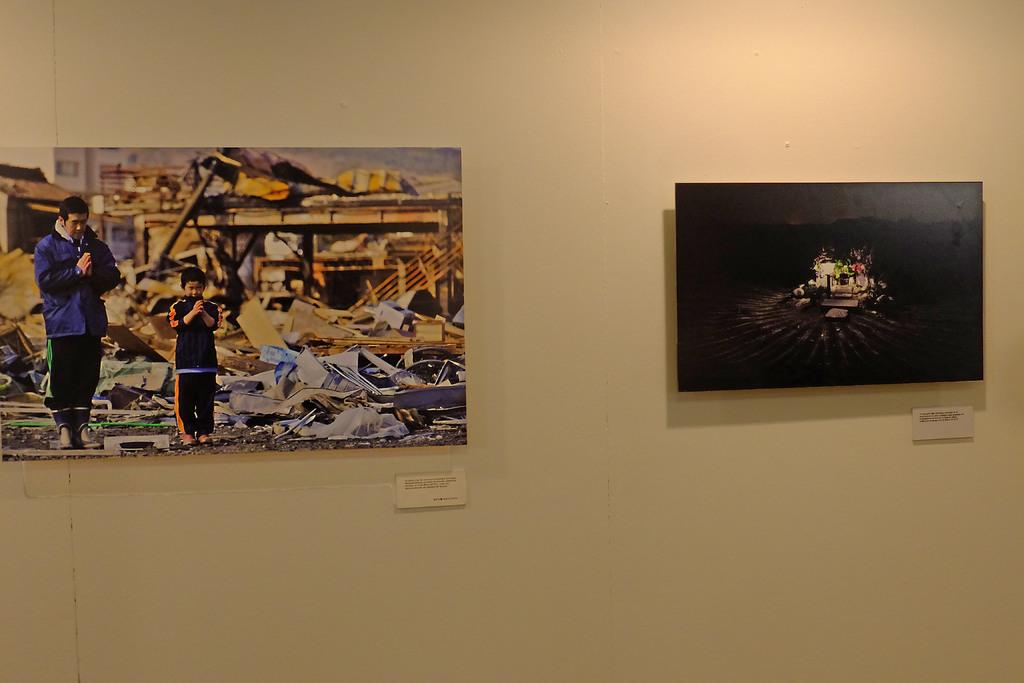What can be seen on the wall in the image? There are photos on the wall in the image. Can you describe one of the photos? In one of the photos, there is a man and a child. What are the man and the child wearing in the photo? The man and the child are wearing clothes and shoes in the photo. What activity are the man and the child engaged in? It appears that the man and the child are praying in the photo. How many boats are visible in the photo with the man and the child? There are no boats visible in the photo with the man and the child; it only shows the man and the child praying. What color is the rose on the table in the photo? There is no rose present in the photo; it only shows the man and the child praying. 